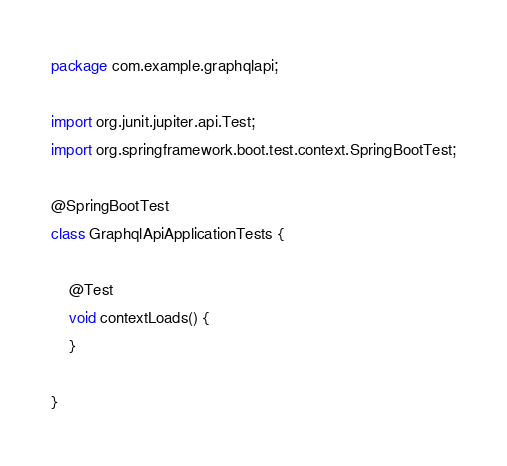<code> <loc_0><loc_0><loc_500><loc_500><_Java_>package com.example.graphqlapi;

import org.junit.jupiter.api.Test;
import org.springframework.boot.test.context.SpringBootTest;

@SpringBootTest
class GraphqlApiApplicationTests {

    @Test
    void contextLoads() {
    }

}
</code> 